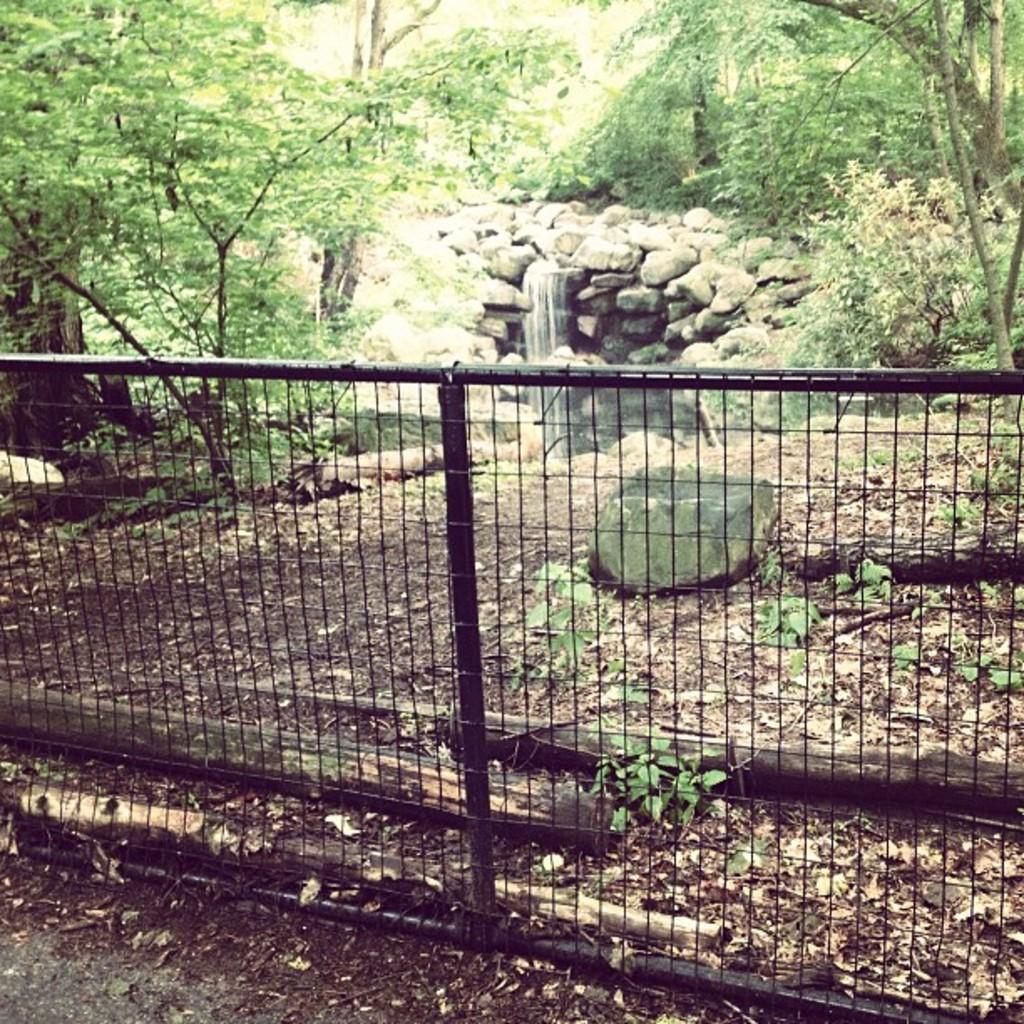Can you describe this image briefly? In this image we can see a fence and group of wood logs placed on the ground. In the center of the image we can see waterfalls, some rocks. At the top of the image we can see a group of trees. 